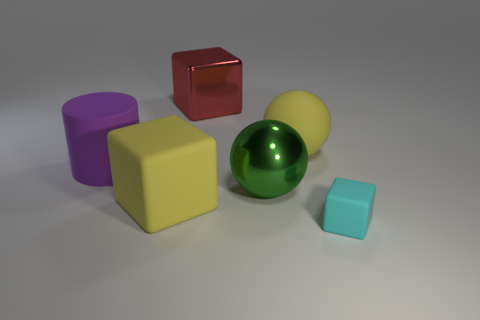How many objects are either big objects in front of the red block or blocks?
Your response must be concise. 6. Is there a large red metallic object of the same shape as the tiny object?
Give a very brief answer. Yes. There is a red object that is the same size as the green object; what is its shape?
Your answer should be very brief. Cube. What is the shape of the object that is behind the yellow thing that is behind the rubber block left of the small cube?
Keep it short and to the point. Cube. There is a red metal thing; does it have the same shape as the object in front of the yellow block?
Provide a short and direct response. Yes. What number of tiny objects are purple matte things or blue metal balls?
Provide a short and direct response. 0. Is there a yellow matte sphere that has the same size as the purple rubber cylinder?
Your response must be concise. Yes. What is the color of the thing that is right of the yellow rubber thing behind the large yellow object that is in front of the rubber sphere?
Your response must be concise. Cyan. Do the cyan cube and the yellow object behind the purple cylinder have the same material?
Provide a short and direct response. Yes. The other thing that is the same shape as the green metallic thing is what size?
Provide a succinct answer. Large. 